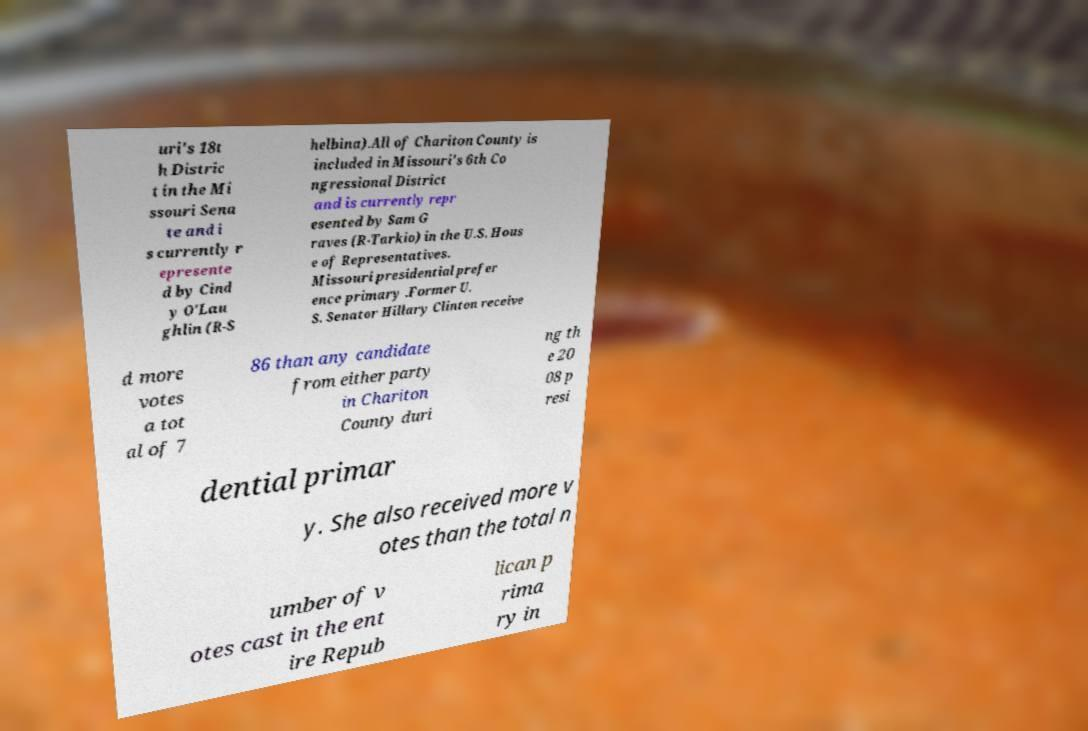Could you assist in decoding the text presented in this image and type it out clearly? uri's 18t h Distric t in the Mi ssouri Sena te and i s currently r epresente d by Cind y O'Lau ghlin (R-S helbina).All of Chariton County is included in Missouri's 6th Co ngressional District and is currently repr esented by Sam G raves (R-Tarkio) in the U.S. Hous e of Representatives. Missouri presidential prefer ence primary .Former U. S. Senator Hillary Clinton receive d more votes a tot al of 7 86 than any candidate from either party in Chariton County duri ng th e 20 08 p resi dential primar y. She also received more v otes than the total n umber of v otes cast in the ent ire Repub lican p rima ry in 